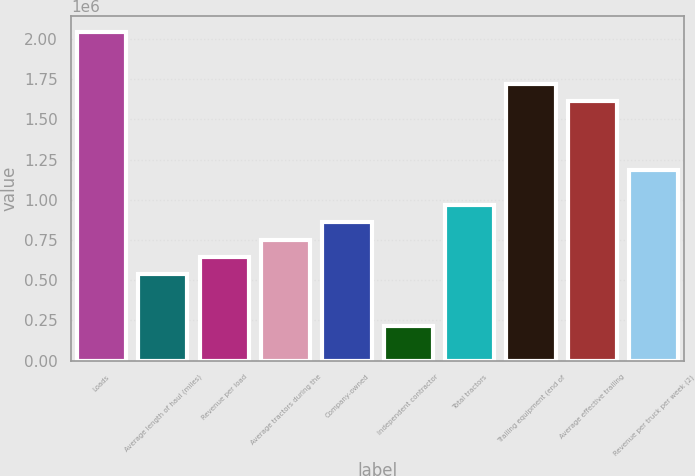Convert chart to OTSL. <chart><loc_0><loc_0><loc_500><loc_500><bar_chart><fcel>Loads<fcel>Average length of haul (miles)<fcel>Revenue per load<fcel>Average tractors during the<fcel>Company-owned<fcel>Independent contractor<fcel>Total tractors<fcel>Trailing equipment (end of<fcel>Average effective trailing<fcel>Revenue per truck per week (2)<nl><fcel>2.04254e+06<fcel>537521<fcel>645022<fcel>752523<fcel>860024<fcel>215017<fcel>967526<fcel>1.72003e+06<fcel>1.61253e+06<fcel>1.18253e+06<nl></chart> 